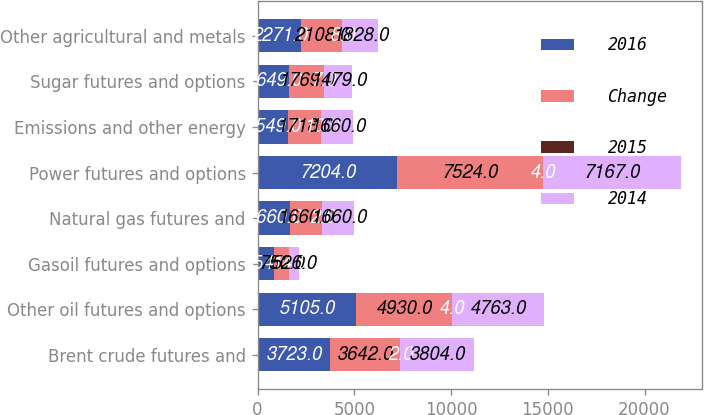Convert chart to OTSL. <chart><loc_0><loc_0><loc_500><loc_500><stacked_bar_chart><ecel><fcel>Brent crude futures and<fcel>Other oil futures and options<fcel>Gasoil futures and options<fcel>Natural gas futures and<fcel>Power futures and options<fcel>Emissions and other energy<fcel>Sugar futures and options<fcel>Other agricultural and metals<nl><fcel>2016<fcel>3723<fcel>5105<fcel>854<fcel>1660<fcel>7204<fcel>1549<fcel>1649<fcel>2271<nl><fcel>Change<fcel>3642<fcel>4930<fcel>750<fcel>1660<fcel>7524<fcel>1718<fcel>1769<fcel>2108<nl><fcel>2015<fcel>2<fcel>4<fcel>14<fcel>2<fcel>4<fcel>10<fcel>7<fcel>8<nl><fcel>2014<fcel>3804<fcel>4763<fcel>526<fcel>1660<fcel>7167<fcel>1660<fcel>1479<fcel>1828<nl></chart> 